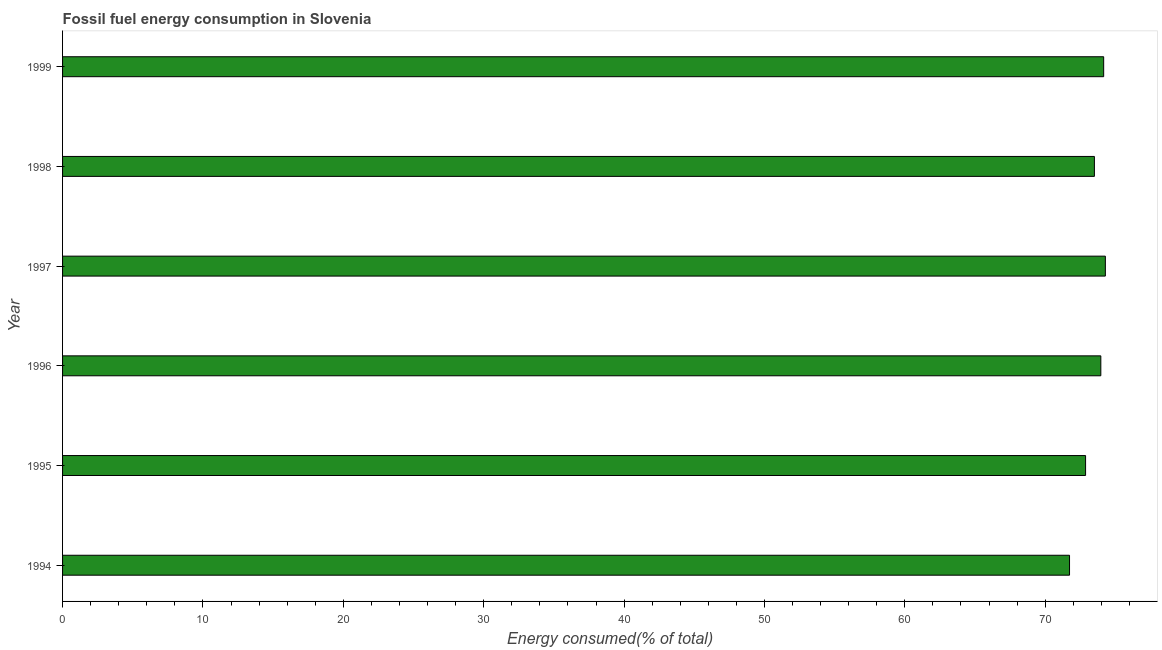What is the title of the graph?
Ensure brevity in your answer.  Fossil fuel energy consumption in Slovenia. What is the label or title of the X-axis?
Make the answer very short. Energy consumed(% of total). What is the label or title of the Y-axis?
Your answer should be very brief. Year. What is the fossil fuel energy consumption in 1995?
Provide a succinct answer. 72.88. Across all years, what is the maximum fossil fuel energy consumption?
Ensure brevity in your answer.  74.28. Across all years, what is the minimum fossil fuel energy consumption?
Your response must be concise. 71.73. In which year was the fossil fuel energy consumption minimum?
Give a very brief answer. 1994. What is the sum of the fossil fuel energy consumption?
Offer a terse response. 440.53. What is the difference between the fossil fuel energy consumption in 1994 and 1998?
Make the answer very short. -1.77. What is the average fossil fuel energy consumption per year?
Provide a succinct answer. 73.42. What is the median fossil fuel energy consumption?
Keep it short and to the point. 73.73. Do a majority of the years between 1997 and 1996 (inclusive) have fossil fuel energy consumption greater than 44 %?
Your answer should be very brief. No. What is the ratio of the fossil fuel energy consumption in 1994 to that in 1999?
Ensure brevity in your answer.  0.97. Is the fossil fuel energy consumption in 1997 less than that in 1998?
Give a very brief answer. No. Is the difference between the fossil fuel energy consumption in 1998 and 1999 greater than the difference between any two years?
Your answer should be compact. No. What is the difference between the highest and the second highest fossil fuel energy consumption?
Provide a succinct answer. 0.12. What is the difference between the highest and the lowest fossil fuel energy consumption?
Offer a terse response. 2.55. What is the difference between two consecutive major ticks on the X-axis?
Your answer should be compact. 10. Are the values on the major ticks of X-axis written in scientific E-notation?
Your response must be concise. No. What is the Energy consumed(% of total) of 1994?
Make the answer very short. 71.73. What is the Energy consumed(% of total) of 1995?
Offer a very short reply. 72.88. What is the Energy consumed(% of total) of 1996?
Provide a succinct answer. 73.96. What is the Energy consumed(% of total) of 1997?
Your response must be concise. 74.28. What is the Energy consumed(% of total) in 1998?
Your response must be concise. 73.51. What is the Energy consumed(% of total) of 1999?
Make the answer very short. 74.17. What is the difference between the Energy consumed(% of total) in 1994 and 1995?
Provide a succinct answer. -1.14. What is the difference between the Energy consumed(% of total) in 1994 and 1996?
Keep it short and to the point. -2.23. What is the difference between the Energy consumed(% of total) in 1994 and 1997?
Your answer should be compact. -2.55. What is the difference between the Energy consumed(% of total) in 1994 and 1998?
Provide a succinct answer. -1.77. What is the difference between the Energy consumed(% of total) in 1994 and 1999?
Ensure brevity in your answer.  -2.43. What is the difference between the Energy consumed(% of total) in 1995 and 1996?
Give a very brief answer. -1.09. What is the difference between the Energy consumed(% of total) in 1995 and 1997?
Provide a short and direct response. -1.41. What is the difference between the Energy consumed(% of total) in 1995 and 1998?
Keep it short and to the point. -0.63. What is the difference between the Energy consumed(% of total) in 1995 and 1999?
Offer a terse response. -1.29. What is the difference between the Energy consumed(% of total) in 1996 and 1997?
Your answer should be compact. -0.32. What is the difference between the Energy consumed(% of total) in 1996 and 1998?
Keep it short and to the point. 0.46. What is the difference between the Energy consumed(% of total) in 1996 and 1999?
Provide a succinct answer. -0.2. What is the difference between the Energy consumed(% of total) in 1997 and 1998?
Keep it short and to the point. 0.78. What is the difference between the Energy consumed(% of total) in 1997 and 1999?
Your answer should be compact. 0.12. What is the difference between the Energy consumed(% of total) in 1998 and 1999?
Offer a terse response. -0.66. What is the ratio of the Energy consumed(% of total) in 1994 to that in 1999?
Keep it short and to the point. 0.97. What is the ratio of the Energy consumed(% of total) in 1995 to that in 1996?
Your answer should be compact. 0.98. What is the ratio of the Energy consumed(% of total) in 1995 to that in 1997?
Keep it short and to the point. 0.98. What is the ratio of the Energy consumed(% of total) in 1995 to that in 1998?
Provide a succinct answer. 0.99. What is the ratio of the Energy consumed(% of total) in 1995 to that in 1999?
Offer a very short reply. 0.98. What is the ratio of the Energy consumed(% of total) in 1996 to that in 1997?
Your answer should be very brief. 1. What is the ratio of the Energy consumed(% of total) in 1996 to that in 1998?
Give a very brief answer. 1.01. What is the ratio of the Energy consumed(% of total) in 1996 to that in 1999?
Keep it short and to the point. 1. What is the ratio of the Energy consumed(% of total) in 1997 to that in 1998?
Your answer should be compact. 1.01. What is the ratio of the Energy consumed(% of total) in 1997 to that in 1999?
Your response must be concise. 1. 